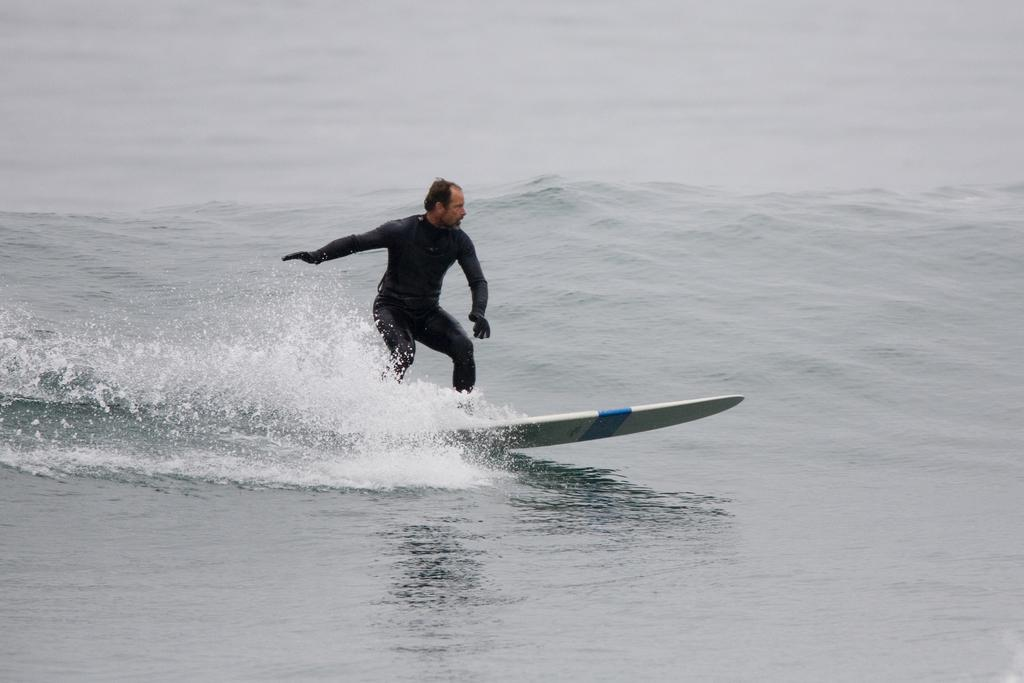What is happening in the image? There is a person in the image who is surfing on the water. Can you describe the person's activity in more detail? The person is standing on a surfboard and riding the waves on the water. What type of paint is the doctor using to play the drum in the image? There is no doctor, drum, or paint present in the image. The image only features a person surfing on the water. 